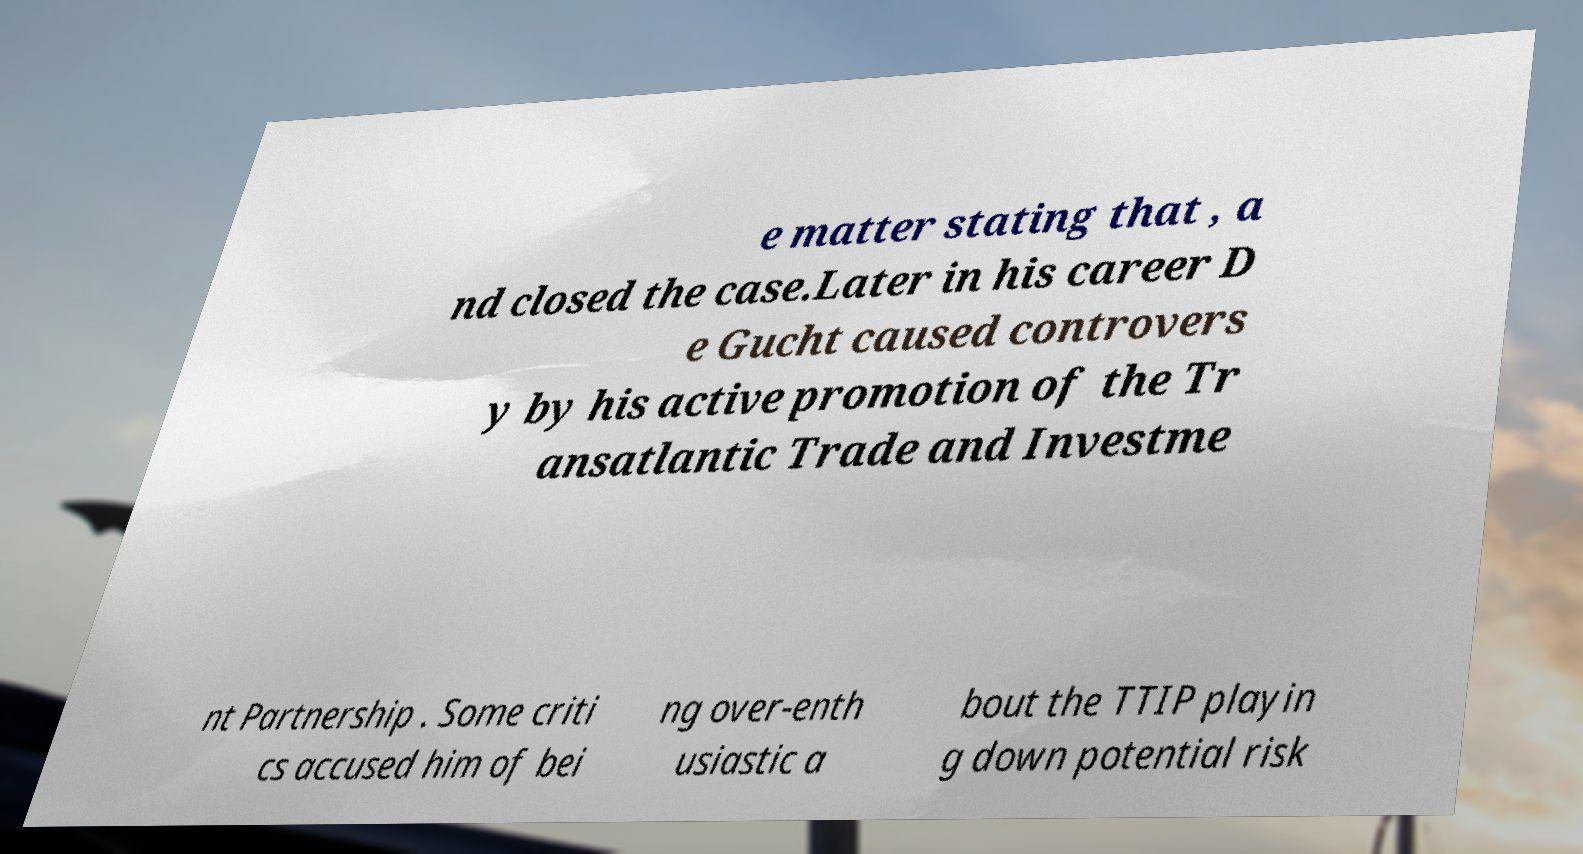Can you read and provide the text displayed in the image?This photo seems to have some interesting text. Can you extract and type it out for me? e matter stating that , a nd closed the case.Later in his career D e Gucht caused controvers y by his active promotion of the Tr ansatlantic Trade and Investme nt Partnership . Some criti cs accused him of bei ng over-enth usiastic a bout the TTIP playin g down potential risk 